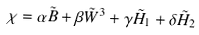Convert formula to latex. <formula><loc_0><loc_0><loc_500><loc_500>\chi = \alpha \tilde { B } + \beta \tilde { W } ^ { 3 } + \gamma \tilde { H } _ { 1 } + \delta \tilde { H } _ { 2 }</formula> 